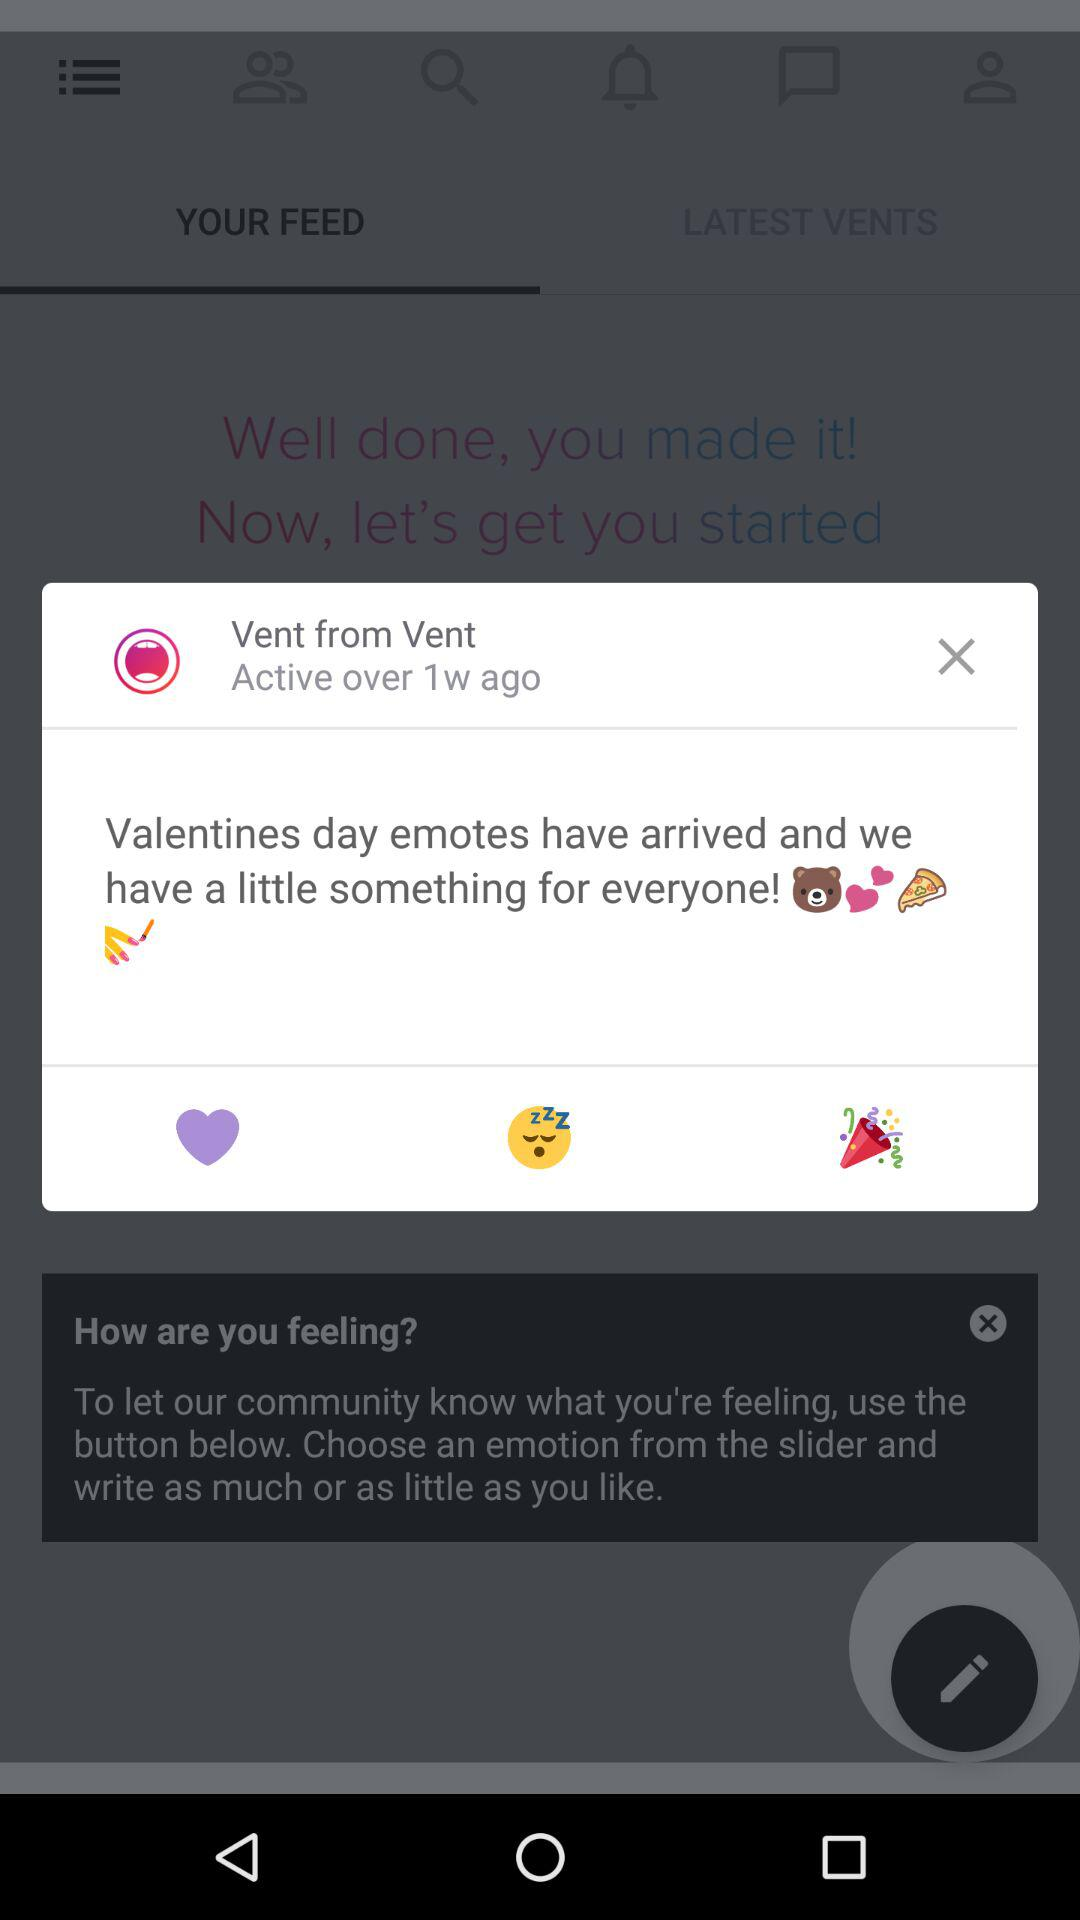When was the user active? The user was active over one week ago. 